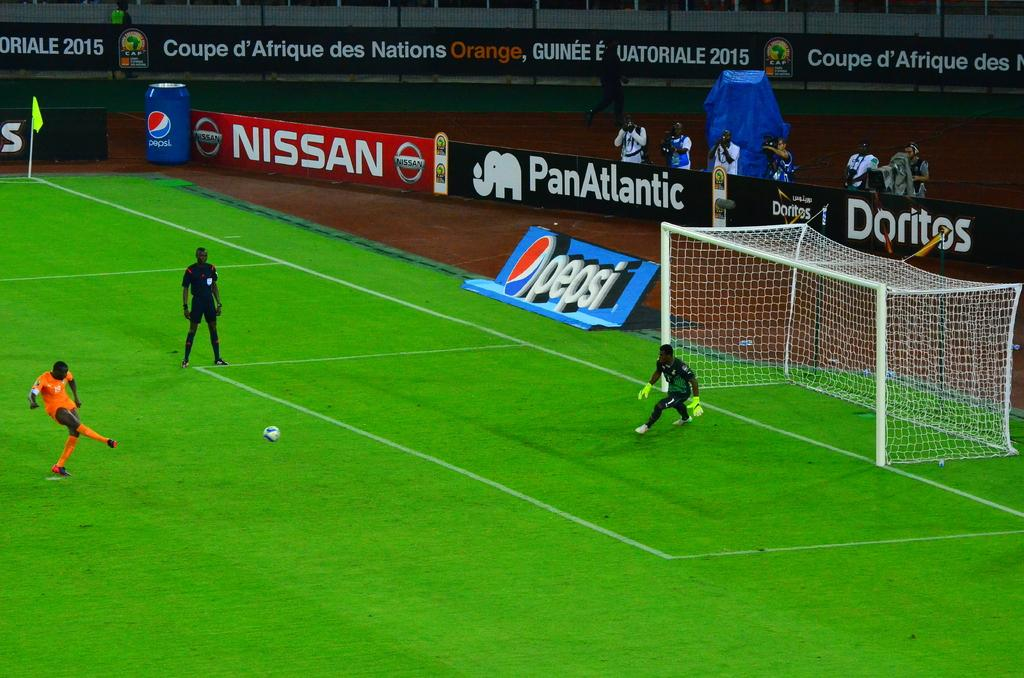<image>
Present a compact description of the photo's key features. Two soccer teams are playing against one another with Nissan, PanAtlantic, and Doritos banners surrounding the field. 